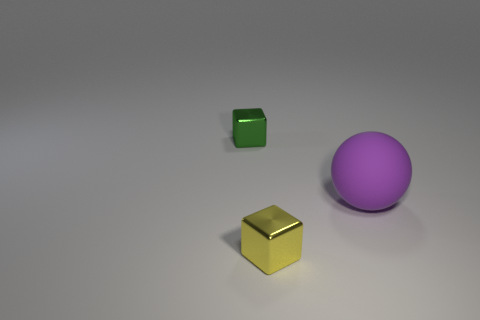Add 3 small green rubber things. How many objects exist? 6 Subtract all balls. How many objects are left? 2 Subtract 0 yellow cylinders. How many objects are left? 3 Subtract all large red matte balls. Subtract all small green metal objects. How many objects are left? 2 Add 1 small green shiny blocks. How many small green shiny blocks are left? 2 Add 1 yellow things. How many yellow things exist? 2 